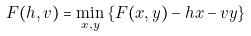Convert formula to latex. <formula><loc_0><loc_0><loc_500><loc_500>F ( h , v ) = \min _ { x , y } \left \{ F ( x , y ) - h x - v y \right \}</formula> 